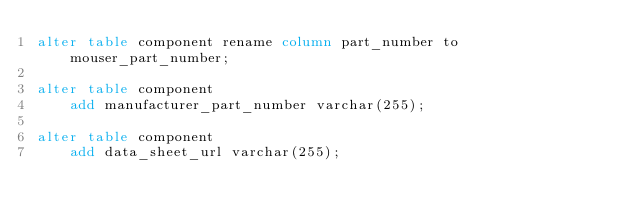Convert code to text. <code><loc_0><loc_0><loc_500><loc_500><_SQL_>alter table component rename column part_number to mouser_part_number;

alter table component
    add manufacturer_part_number varchar(255);

alter table component
    add data_sheet_url varchar(255);</code> 